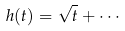<formula> <loc_0><loc_0><loc_500><loc_500>h ( t ) = \sqrt { t } + \cdots</formula> 